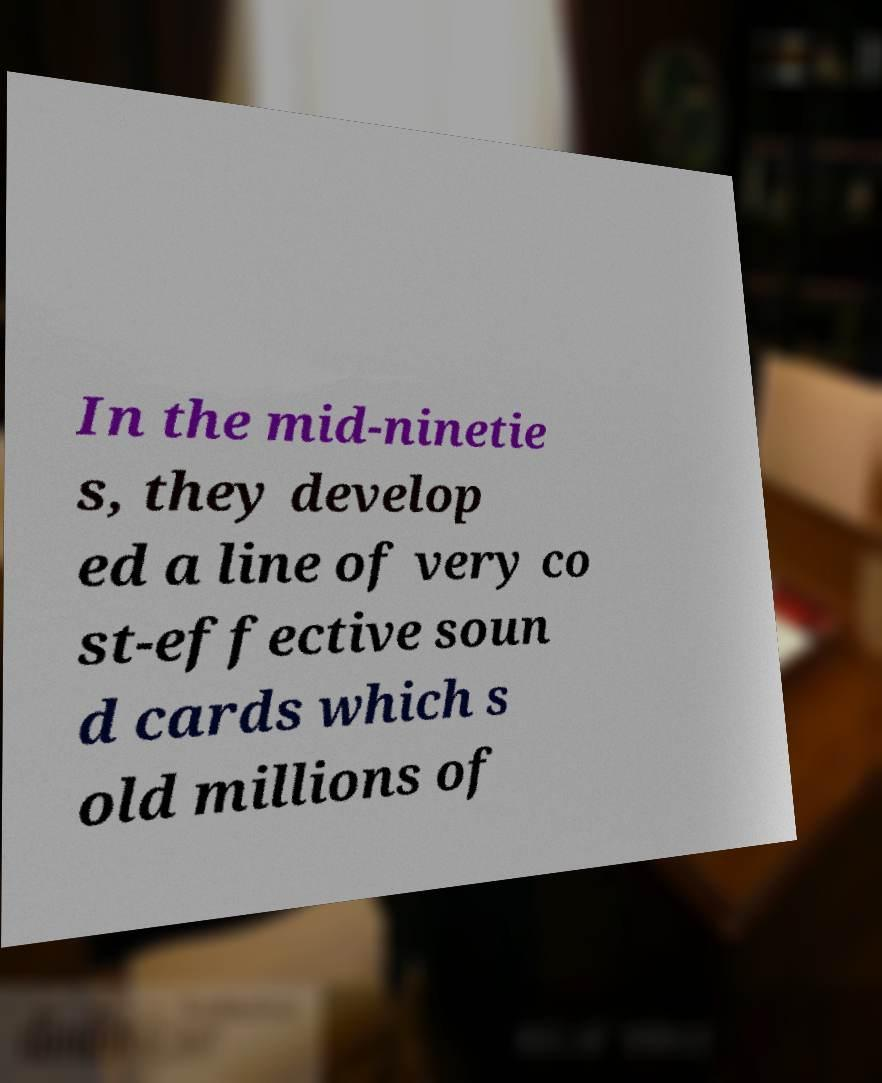Can you accurately transcribe the text from the provided image for me? In the mid-ninetie s, they develop ed a line of very co st-effective soun d cards which s old millions of 